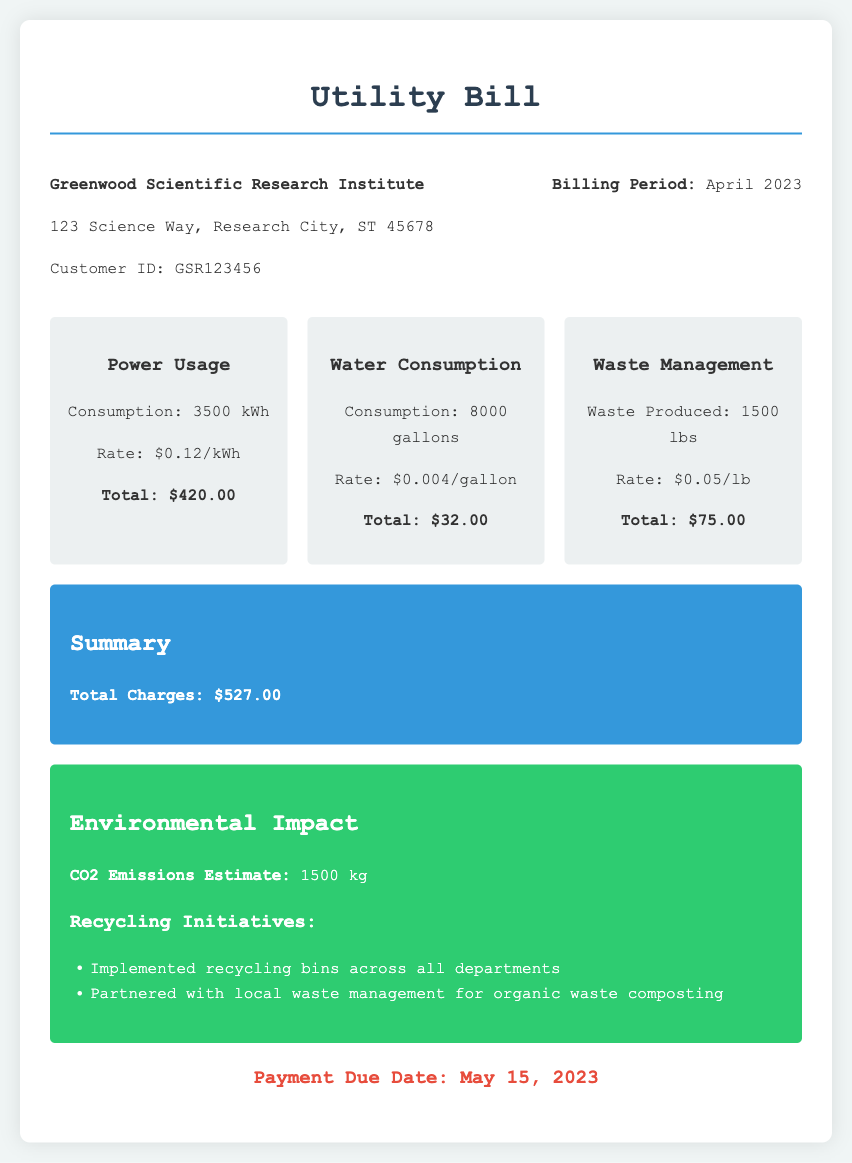what is the total charge for power usage? The total charge for power usage is listed under the Power Usage section of the document, which is $420.00.
Answer: $420.00 what is the rate for water consumption? The rate for water consumption can be found in the Water Consumption section of the document, which is $0.004/gallon.
Answer: $0.004/gallon how much waste was produced by the institute? The amount of waste produced is detailed in the Waste Management section of the document, which states 1500 lbs.
Answer: 1500 lbs what is the total charge for the utility bill? The total charge for the utility bill is summarized at the end of the document, which is $527.00.
Answer: $527.00 when is the payment due date? The payment due date is mentioned at the bottom of the document, which is May 15, 2023.
Answer: May 15, 2023 how many gallons of water were consumed? The water consumption is specified in the Water Consumption section, which is 8000 gallons.
Answer: 8000 gallons what is the estimated CO2 emissions? The estimated CO2 emissions are given in the Environmental Impact section of the document, which states 1500 kg.
Answer: 1500 kg what recycling initiatives has the institute implemented? The recycling initiatives can be found in the Environmental Impact section, which includes the implementation of recycling bins across all departments and partnering with local waste management for composting.
Answer: Recycling bins and composting partnerships what is the rate for waste management? The rate for waste management is detailed in the Waste Management section of the document, which is $0.05/lb.
Answer: $0.05/lb 